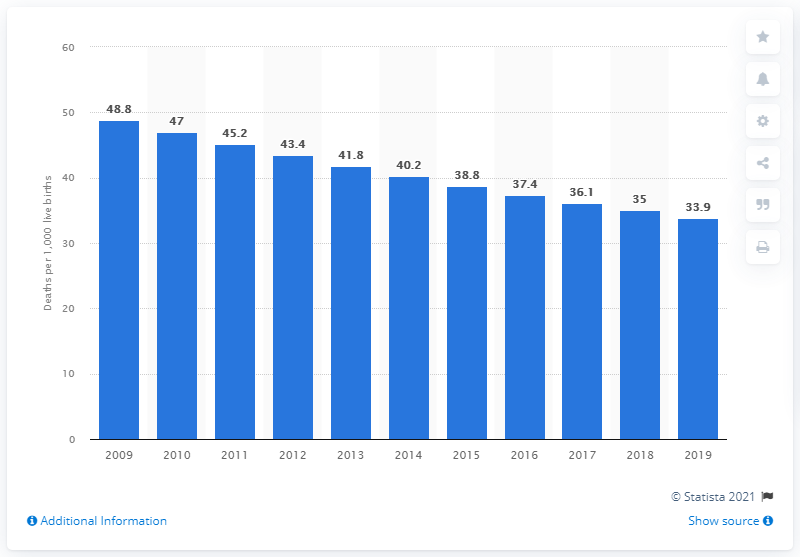Outline some significant characteristics in this image. The infant mortality rate in Ghana in 2019 was 33.9. 